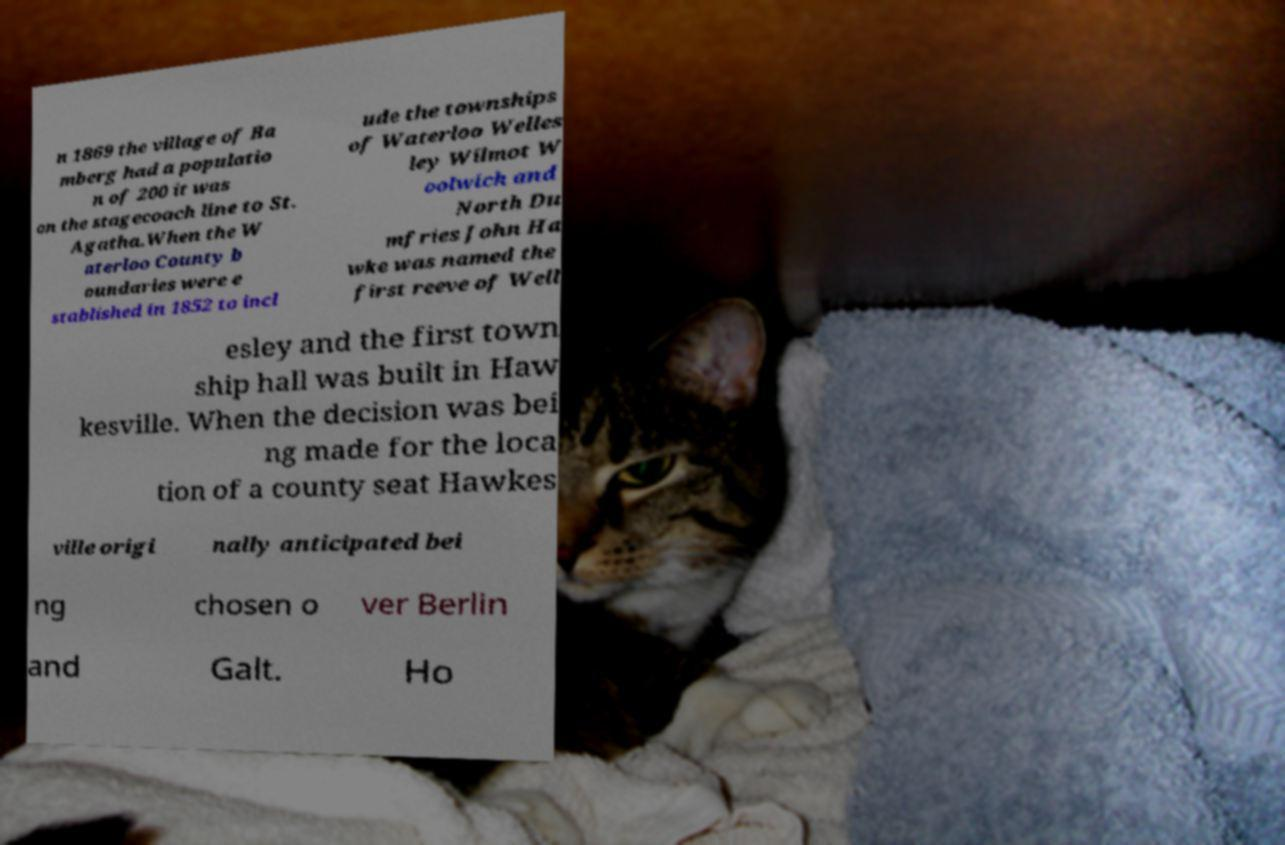I need the written content from this picture converted into text. Can you do that? n 1869 the village of Ba mberg had a populatio n of 200 it was on the stagecoach line to St. Agatha.When the W aterloo County b oundaries were e stablished in 1852 to incl ude the townships of Waterloo Welles ley Wilmot W oolwich and North Du mfries John Ha wke was named the first reeve of Well esley and the first town ship hall was built in Haw kesville. When the decision was bei ng made for the loca tion of a county seat Hawkes ville origi nally anticipated bei ng chosen o ver Berlin and Galt. Ho 